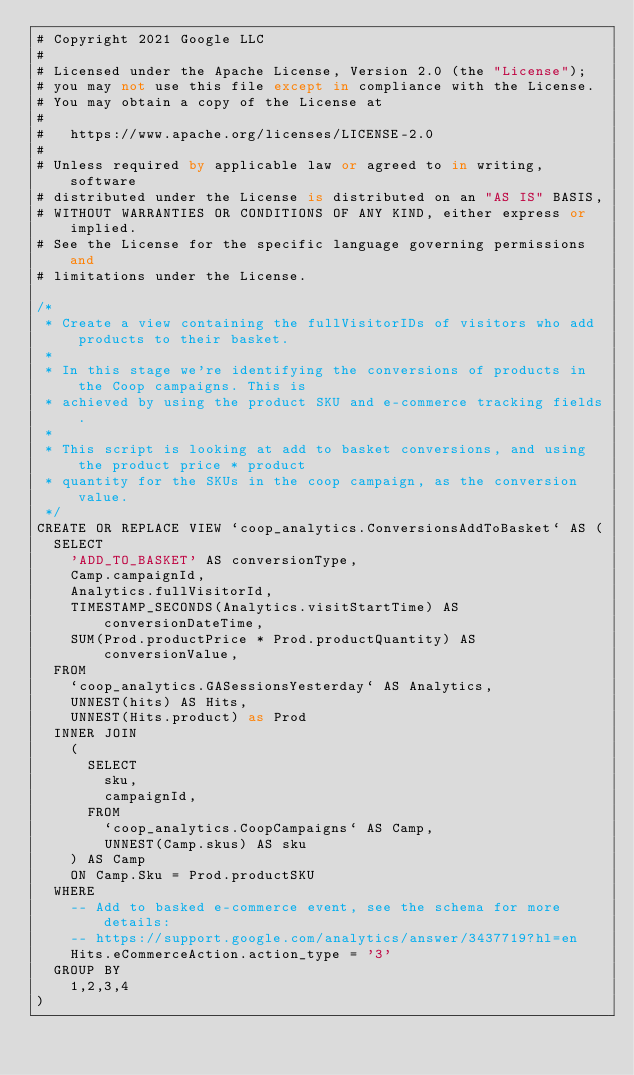Convert code to text. <code><loc_0><loc_0><loc_500><loc_500><_SQL_># Copyright 2021 Google LLC
#
# Licensed under the Apache License, Version 2.0 (the "License");
# you may not use this file except in compliance with the License.
# You may obtain a copy of the License at
#
#   https://www.apache.org/licenses/LICENSE-2.0
#
# Unless required by applicable law or agreed to in writing, software
# distributed under the License is distributed on an "AS IS" BASIS,
# WITHOUT WARRANTIES OR CONDITIONS OF ANY KIND, either express or implied.
# See the License for the specific language governing permissions and
# limitations under the License.

/*
 * Create a view containing the fullVisitorIDs of visitors who add products to their basket.
 *
 * In this stage we're identifying the conversions of products in the Coop campaigns. This is
 * achieved by using the product SKU and e-commerce tracking fields.
 *
 * This script is looking at add to basket conversions, and using the product price * product
 * quantity for the SKUs in the coop campaign, as the conversion value.
 */
CREATE OR REPLACE VIEW `coop_analytics.ConversionsAddToBasket` AS (
  SELECT
    'ADD_TO_BASKET' AS conversionType,
    Camp.campaignId,
    Analytics.fullVisitorId,
    TIMESTAMP_SECONDS(Analytics.visitStartTime) AS conversionDateTime,
    SUM(Prod.productPrice * Prod.productQuantity) AS conversionValue,
  FROM
    `coop_analytics.GASessionsYesterday` AS Analytics,
    UNNEST(hits) AS Hits,
    UNNEST(Hits.product) as Prod
  INNER JOIN
    (
      SELECT
        sku,
        campaignId,
      FROM
        `coop_analytics.CoopCampaigns` AS Camp,
        UNNEST(Camp.skus) AS sku
    ) AS Camp
    ON Camp.Sku = Prod.productSKU
  WHERE
    -- Add to basked e-commerce event, see the schema for more details:
    -- https://support.google.com/analytics/answer/3437719?hl=en
    Hits.eCommerceAction.action_type = '3'
  GROUP BY
    1,2,3,4
)
</code> 